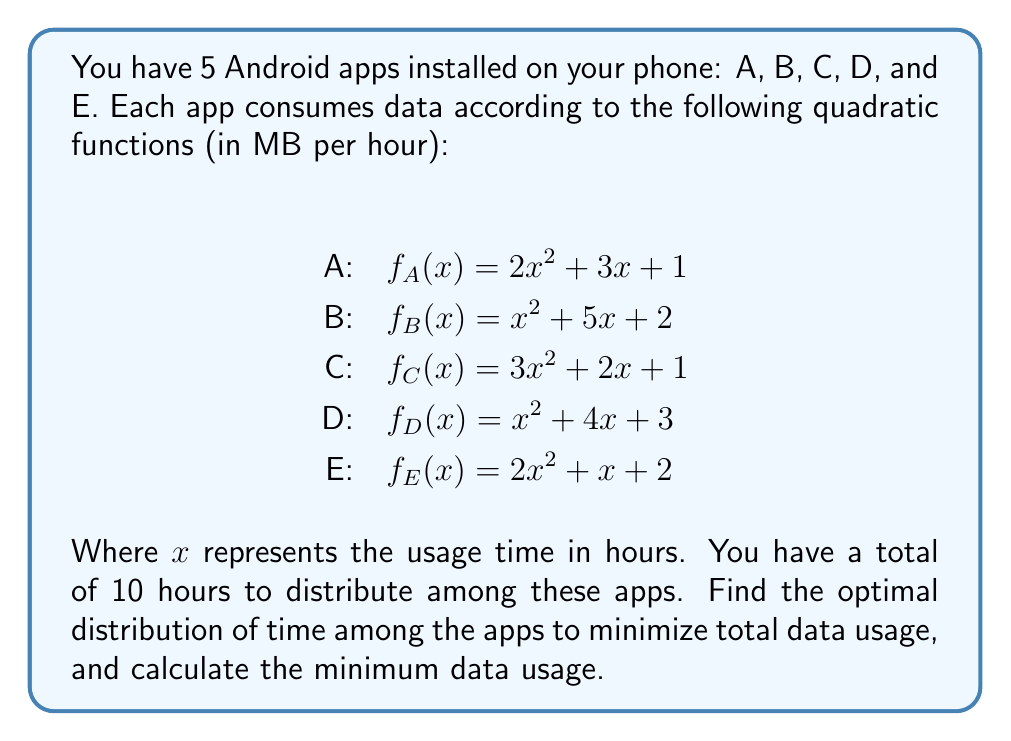What is the answer to this math problem? To solve this optimization problem, we'll use the method of Lagrange multipliers, as we have a constraint (total time = 10 hours) and we want to minimize the total data usage.

Let $x_A, x_B, x_C, x_D,$ and $x_E$ be the time spent on apps A, B, C, D, and E respectively.

The objective function to minimize is:
$$F = f_A(x_A) + f_B(x_B) + f_C(x_C) + f_D(x_D) + f_E(x_E)$$

The constraint is:
$$g = x_A + x_B + x_C + x_D + x_E - 10 = 0$$

We form the Lagrangian:
$$L = F + \lambda g$$

Now, we take partial derivatives and set them to zero:

$$\frac{\partial L}{\partial x_A} = 4x_A + 3 + \lambda = 0$$
$$\frac{\partial L}{\partial x_B} = 2x_B + 5 + \lambda = 0$$
$$\frac{\partial L}{\partial x_C} = 6x_C + 2 + \lambda = 0$$
$$\frac{\partial L}{\partial x_D} = 2x_D + 4 + \lambda = 0$$
$$\frac{\partial L}{\partial x_E} = 4x_E + 1 + \lambda = 0$$
$$\frac{\partial L}{\partial \lambda} = x_A + x_B + x_C + x_D + x_E - 10 = 0$$

From these equations, we can express each $x_i$ in terms of $\lambda$:

$$x_A = -\frac{\lambda + 3}{4}$$
$$x_B = -\frac{\lambda + 5}{2}$$
$$x_C = -\frac{\lambda + 2}{6}$$
$$x_D = -\frac{\lambda + 4}{2}$$
$$x_E = -\frac{\lambda + 1}{4}$$

Substituting these into the constraint equation:

$$-\frac{\lambda + 3}{4} - \frac{\lambda + 5}{2} - \frac{\lambda + 2}{6} - \frac{\lambda + 4}{2} - \frac{\lambda + 1}{4} = 10$$

Solving this equation, we get $\lambda = -3.6$

Now we can find the optimal times:

$$x_A = 0.15\text{ hours}$$
$$x_B = 0.7\text{ hours}$$
$$x_C = 0.2667\text{ hours}$$
$$x_D = 0.2\text{ hours}$$
$$x_E = 0.65\text{ hours}$$

The minimum data usage is:

$$F_{min} = f_A(0.15) + f_B(0.7) + f_C(0.2667) + f_D(0.2) + f_E(0.65)$$
$$= 1.5675 + 5.49 + 1.6178 + 3.88 + 3.0975$$
$$= 15.6528\text{ MB}$$
Answer: The optimal distribution of time (in hours) among the apps is:
A: 0.15, B: 0.7, C: 0.2667, D: 0.2, E: 0.65

The minimum total data usage is 15.6528 MB. 